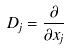<formula> <loc_0><loc_0><loc_500><loc_500>D _ { j } = \frac { \partial } { \partial x _ { j } }</formula> 